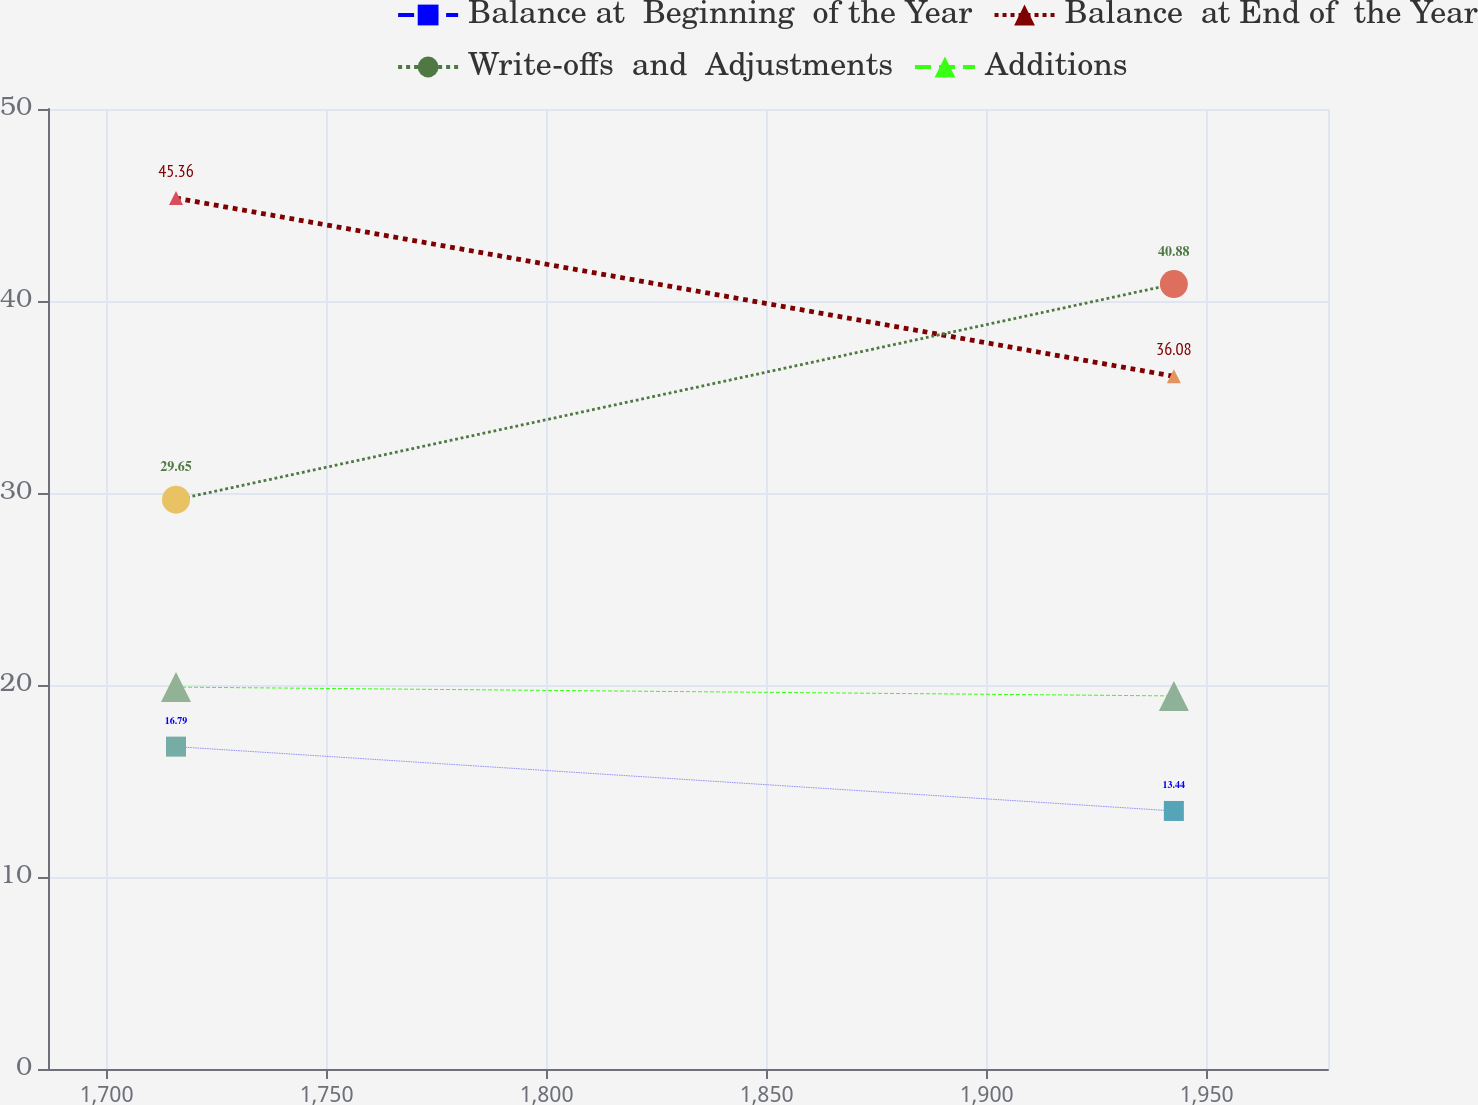Convert chart. <chart><loc_0><loc_0><loc_500><loc_500><line_chart><ecel><fcel>Balance at  Beginning  of the Year<fcel>Balance  at End of  the Year<fcel>Write-offs  and  Adjustments<fcel>Additions<nl><fcel>1715.77<fcel>16.79<fcel>45.36<fcel>29.65<fcel>19.89<nl><fcel>1942.55<fcel>13.44<fcel>36.08<fcel>40.88<fcel>19.43<nl><fcel>2006.67<fcel>12.92<fcel>41.35<fcel>35.91<fcel>14.86<nl></chart> 